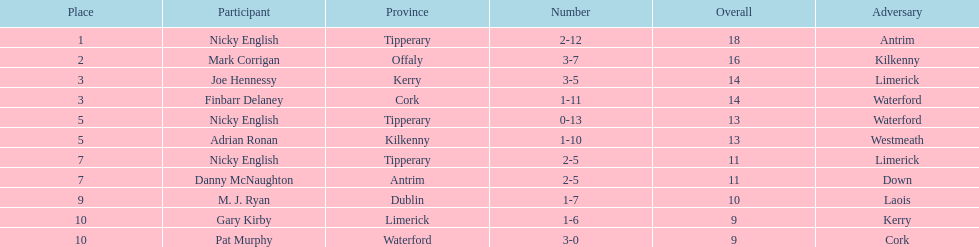What player got 10 total points in their game? M. J. Ryan. 